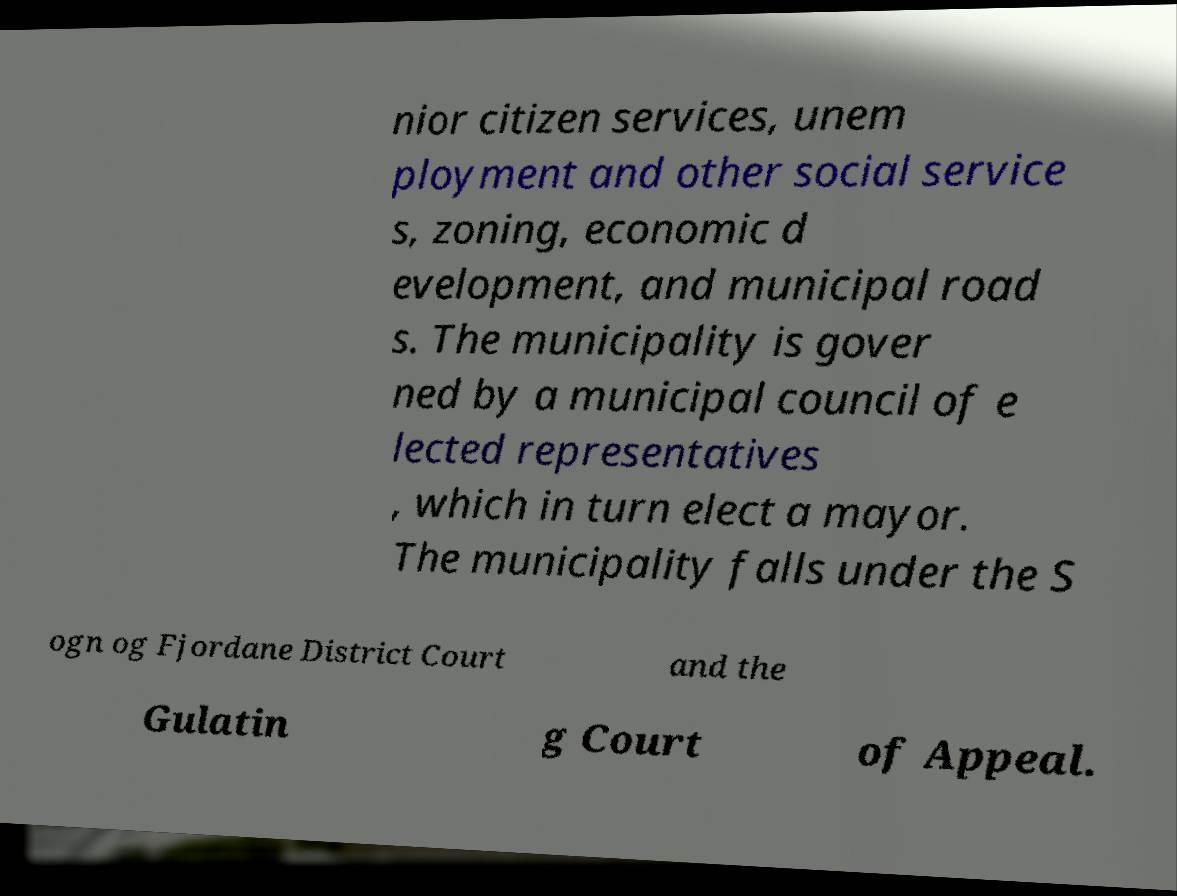Can you read and provide the text displayed in the image?This photo seems to have some interesting text. Can you extract and type it out for me? nior citizen services, unem ployment and other social service s, zoning, economic d evelopment, and municipal road s. The municipality is gover ned by a municipal council of e lected representatives , which in turn elect a mayor. The municipality falls under the S ogn og Fjordane District Court and the Gulatin g Court of Appeal. 